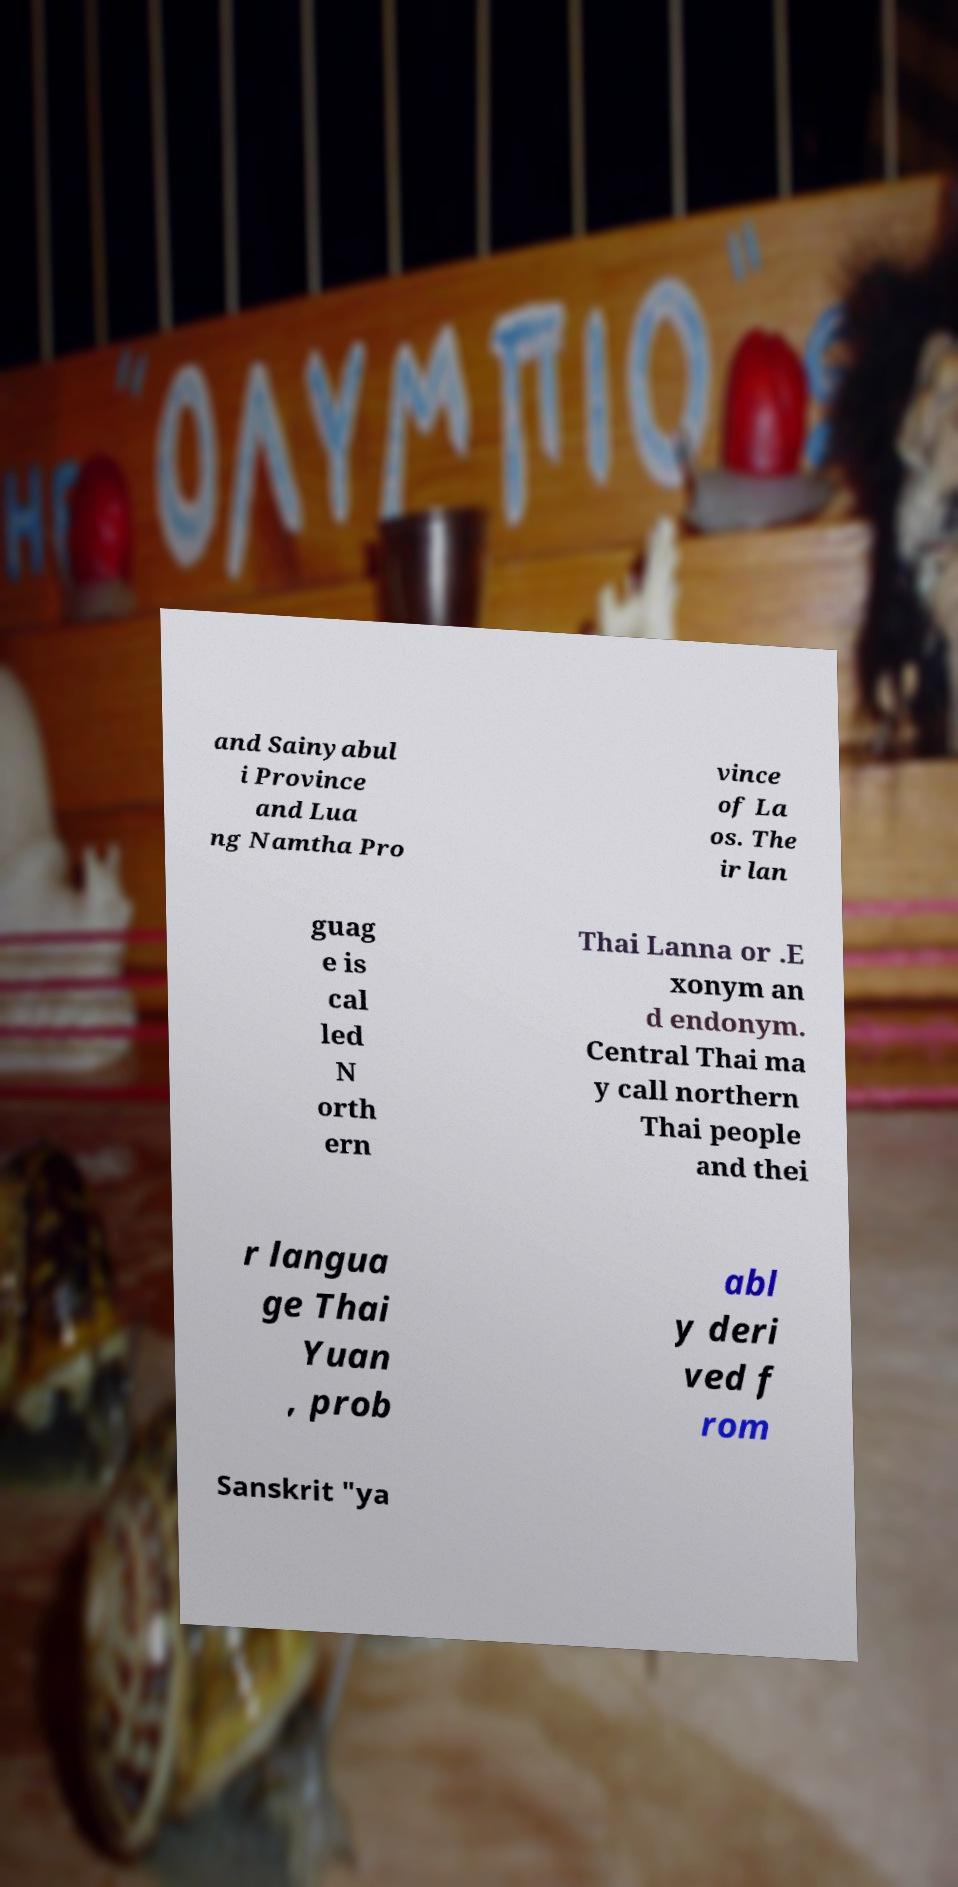Please read and relay the text visible in this image. What does it say? and Sainyabul i Province and Lua ng Namtha Pro vince of La os. The ir lan guag e is cal led N orth ern Thai Lanna or .E xonym an d endonym. Central Thai ma y call northern Thai people and thei r langua ge Thai Yuan , prob abl y deri ved f rom Sanskrit "ya 